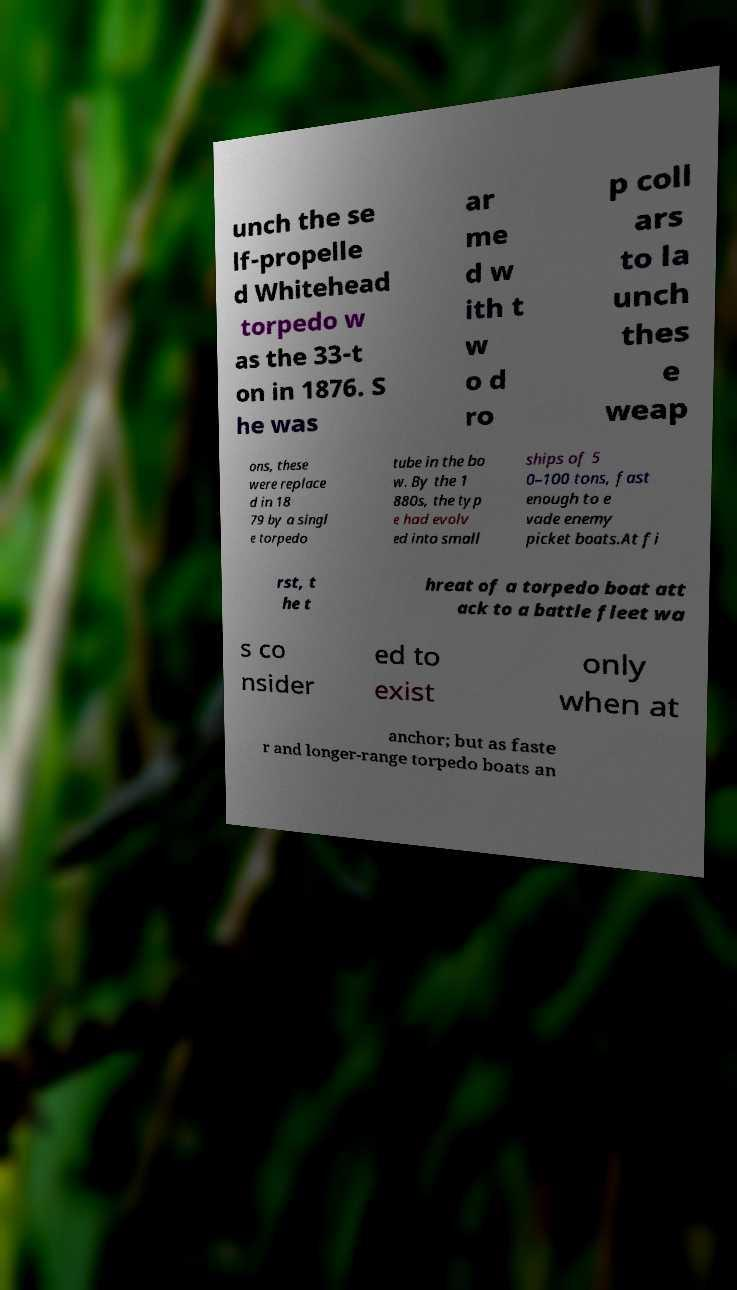Could you assist in decoding the text presented in this image and type it out clearly? unch the se lf-propelle d Whitehead torpedo w as the 33-t on in 1876. S he was ar me d w ith t w o d ro p coll ars to la unch thes e weap ons, these were replace d in 18 79 by a singl e torpedo tube in the bo w. By the 1 880s, the typ e had evolv ed into small ships of 5 0–100 tons, fast enough to e vade enemy picket boats.At fi rst, t he t hreat of a torpedo boat att ack to a battle fleet wa s co nsider ed to exist only when at anchor; but as faste r and longer-range torpedo boats an 